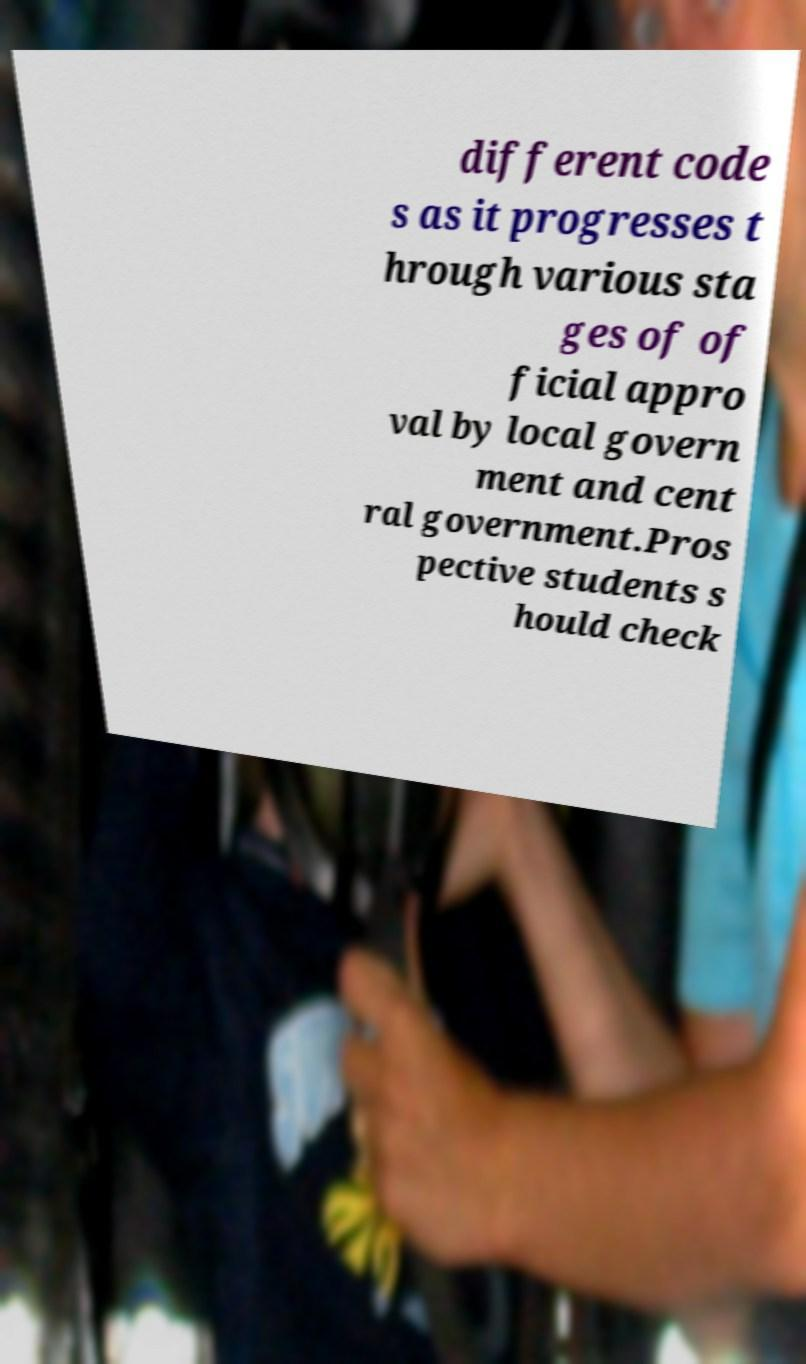Please read and relay the text visible in this image. What does it say? different code s as it progresses t hrough various sta ges of of ficial appro val by local govern ment and cent ral government.Pros pective students s hould check 